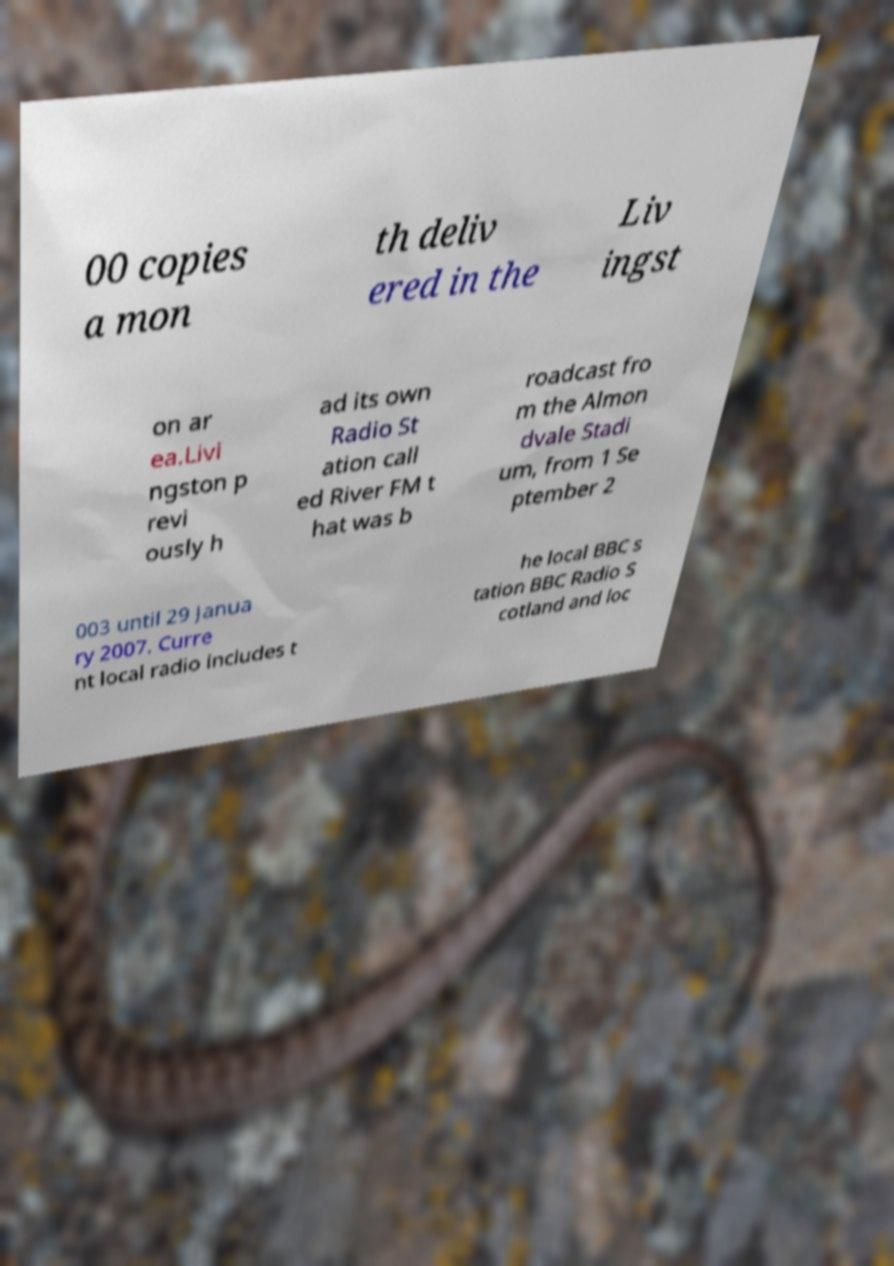Please identify and transcribe the text found in this image. 00 copies a mon th deliv ered in the Liv ingst on ar ea.Livi ngston p revi ously h ad its own Radio St ation call ed River FM t hat was b roadcast fro m the Almon dvale Stadi um, from 1 Se ptember 2 003 until 29 Janua ry 2007. Curre nt local radio includes t he local BBC s tation BBC Radio S cotland and loc 